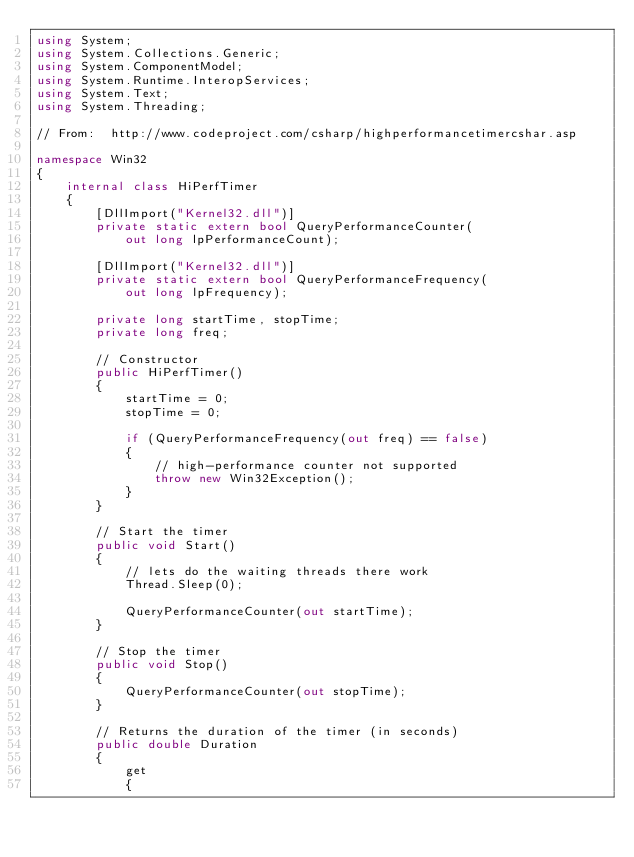Convert code to text. <code><loc_0><loc_0><loc_500><loc_500><_C#_>using System;
using System.Collections.Generic;
using System.ComponentModel;
using System.Runtime.InteropServices;
using System.Text;
using System.Threading;

// From:  http://www.codeproject.com/csharp/highperformancetimercshar.asp

namespace Win32
{
    internal class HiPerfTimer
    {
        [DllImport("Kernel32.dll")]
        private static extern bool QueryPerformanceCounter(
            out long lpPerformanceCount);

        [DllImport("Kernel32.dll")]
        private static extern bool QueryPerformanceFrequency(
            out long lpFrequency);

        private long startTime, stopTime;
        private long freq;

        // Constructor
        public HiPerfTimer()
        {
            startTime = 0;
            stopTime = 0;

            if (QueryPerformanceFrequency(out freq) == false)
            {
                // high-performance counter not supported
                throw new Win32Exception();
            }
        }

        // Start the timer
        public void Start()
        {
            // lets do the waiting threads there work
            Thread.Sleep(0);

            QueryPerformanceCounter(out startTime);
        }

        // Stop the timer
        public void Stop()
        {
            QueryPerformanceCounter(out stopTime);
        }

        // Returns the duration of the timer (in seconds)
        public double Duration
        {
            get
            {</code> 